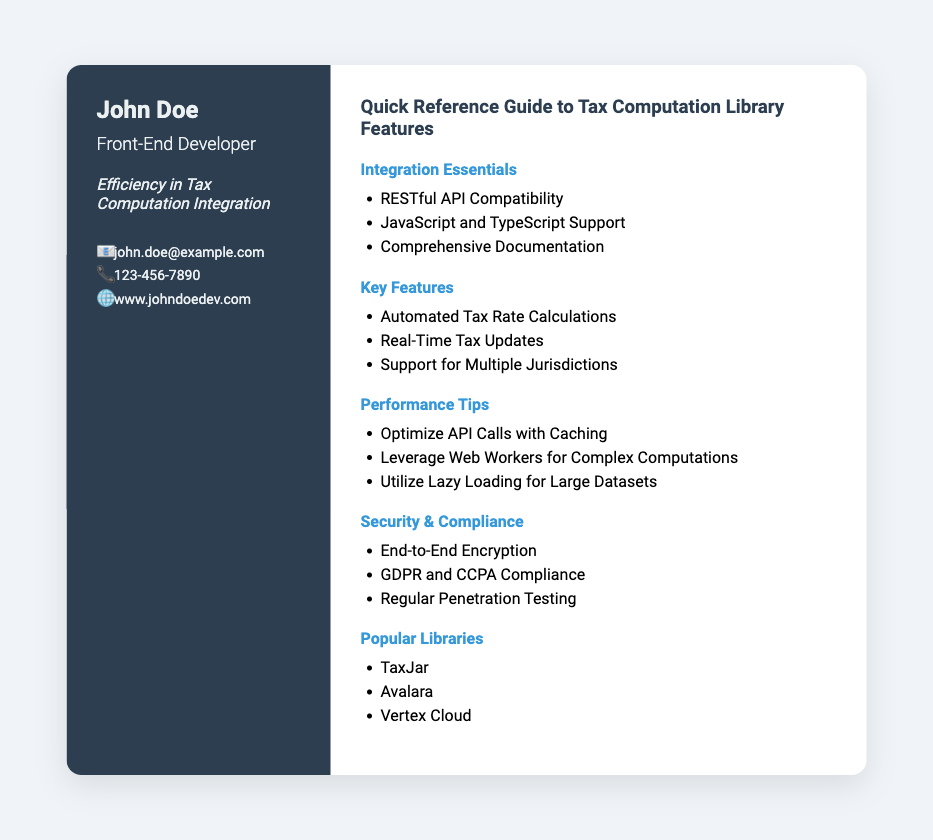What is the name on the business card? The name displayed prominently on the business card is "John Doe."
Answer: John Doe What is the profession listed on the card? The card specifies "Front-End Developer" as the profession of the individual.
Answer: Front-End Developer What feature supports multiple jurisdictions? The document mentions "Support for Multiple Jurisdictions" as a key feature of the library.
Answer: Support for Multiple Jurisdictions How can API calls be optimized? The document suggests optimizing API calls with "Caching."
Answer: Caching Which compliance regulations are mentioned? The document specifies "GDPR and CCPA Compliance" under the security section.
Answer: GDPR and CCPA Compliance What is the tagline presented on the card? The tagline highlights the focus on efficiency in tax computation integration.
Answer: Efficiency in Tax Computation Integration Which library is popular for tax computation? The document lists "TaxJar" as one of the popular libraries in tax computation.
Answer: TaxJar What language supports the library alongside JavaScript? In the integration essentials, the document states that "TypeScript" also supports the library.
Answer: TypeScript What type of encryption is mentioned? The document mentions "End-to-End Encryption" under the security section.
Answer: End-to-End Encryption 